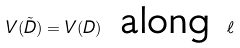<formula> <loc_0><loc_0><loc_500><loc_500>V ( \tilde { D } ) = V ( D ) \text { along } \ell</formula> 